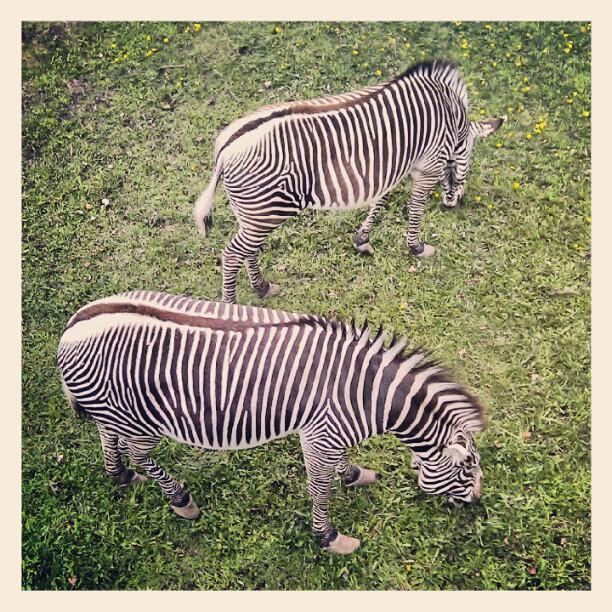How many zebras are in the picture?
Give a very brief answer. 2. 